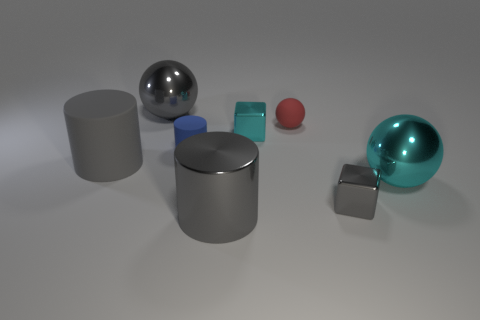What number of large matte things have the same color as the large metal cylinder?
Your answer should be very brief. 1. What is the size of the rubber thing that is the same color as the large metal cylinder?
Your answer should be compact. Large. There is a red sphere; does it have the same size as the shiny sphere that is on the right side of the small gray metal block?
Provide a succinct answer. No. How many balls are big metallic things or small cyan objects?
Provide a short and direct response. 2. What is the size of the gray object that is made of the same material as the red ball?
Ensure brevity in your answer.  Large. Is the size of the matte thing that is in front of the blue cylinder the same as the block that is to the right of the small cyan metal block?
Give a very brief answer. No. How many objects are either small purple matte cylinders or large gray cylinders?
Provide a short and direct response. 2. What shape is the large cyan thing?
Give a very brief answer. Sphere. What size is the metal thing that is the same shape as the tiny blue matte thing?
Offer a terse response. Large. Are there any other things that are made of the same material as the tiny cylinder?
Your response must be concise. Yes. 